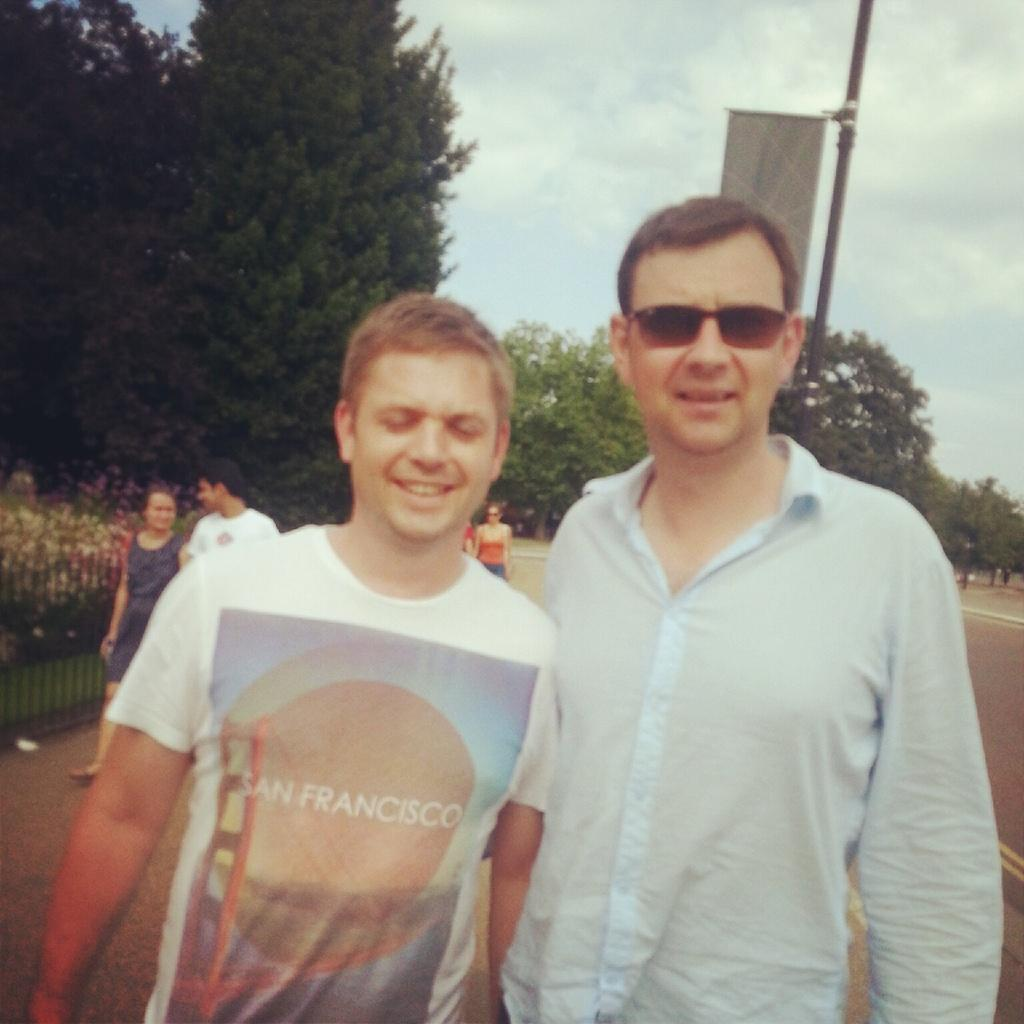How many people are present in the image? There are two people standing in the image. What is one of the men wearing? One of the men is wearing goggles. What can be seen in the background of the image? There is a pole, a banner, a fence, plants, and people in the background of the image. The sky is also visible in the background. What is the condition of the sky in the image? The sky is cloudy in the image. What type of insect can be seen crawling on the wax in the image? There is no insect or wax present in the image. What is the porter doing in the image? There is no porter present in the image. 